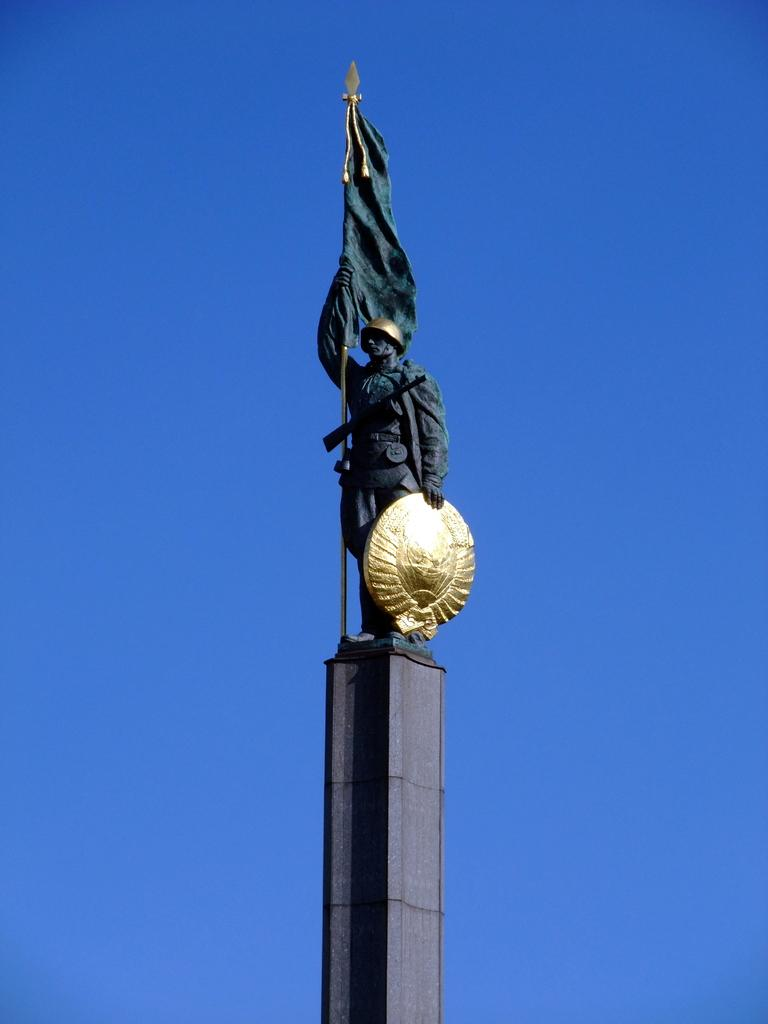What is the main subject of the image? There is a sculpture in the image. Where is the sculpture located? The sculpture is on a tall tower. What is the sculpture holding? The sculpture is holding a flag. What type of produce can be seen growing on the tower in the image? There is no produce visible in the image; the sculpture is holding a flag on a tall tower. How many lizards are climbing on the sculpture in the image? There are no lizards present in the image; the sculpture is holding a flag on a tall tower. 